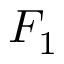Convert formula to latex. <formula><loc_0><loc_0><loc_500><loc_500>F _ { 1 }</formula> 